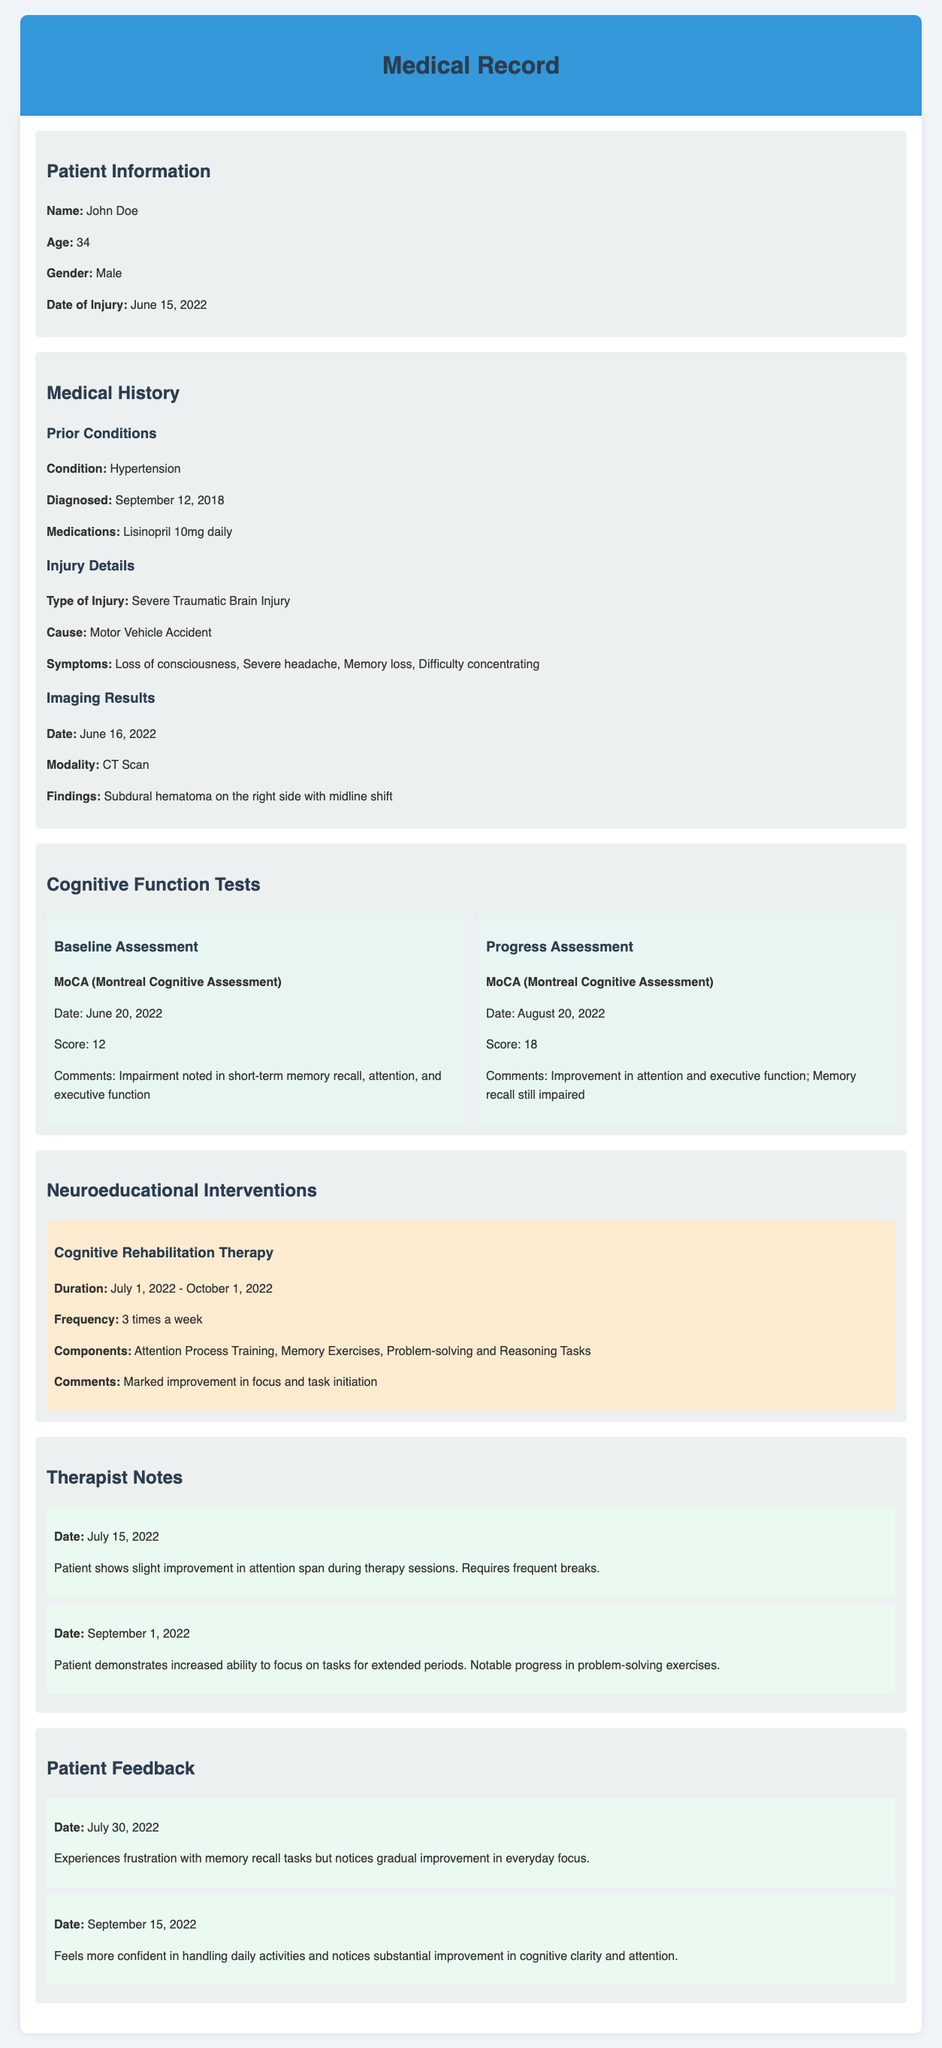What is the patient's name? The patient's name is provided in the "Patient Information" section of the document.
Answer: John Doe What type of injury did the patient sustain? The type of injury is detailed in the "Injury Details" subsection under "Medical History".
Answer: Severe Traumatic Brain Injury What was the MoCA score on the baseline assessment? The MoCA score is indicated in the "Cognitive Function Tests" section under "Baseline Assessment".
Answer: 12 When did the Cognitive Rehabilitation Therapy start? The start date of the therapy is given in the "Neuroeducational Interventions" section.
Answer: July 1, 2022 What improvement was noted in patient feedback on September 15, 2022? The feedback on this date highlights the patient's improvement in handling daily activities.
Answer: Substantial improvement in cognitive clarity and attention What findings were reported from the CT scan? The findings from the CT scan are noted in the "Imaging Results" subsection under "Medical History".
Answer: Subdural hematoma on the right side with midline shift What was the frequency of Cognitive Rehabilitation Therapy sessions? The frequency of the therapy sessions is specified in the "Neuroeducational Interventions" section.
Answer: 3 times a week What symptom was reported on the patient's injury? Symptoms are listed under the "Injury Details" subsection in the "Medical History" section.
Answer: Memory loss What specific component was included in the Cognitive Rehabilitation Therapy? The components of the therapy are mentioned in the "Neuroeducational Interventions" section.
Answer: Memory Exercises 